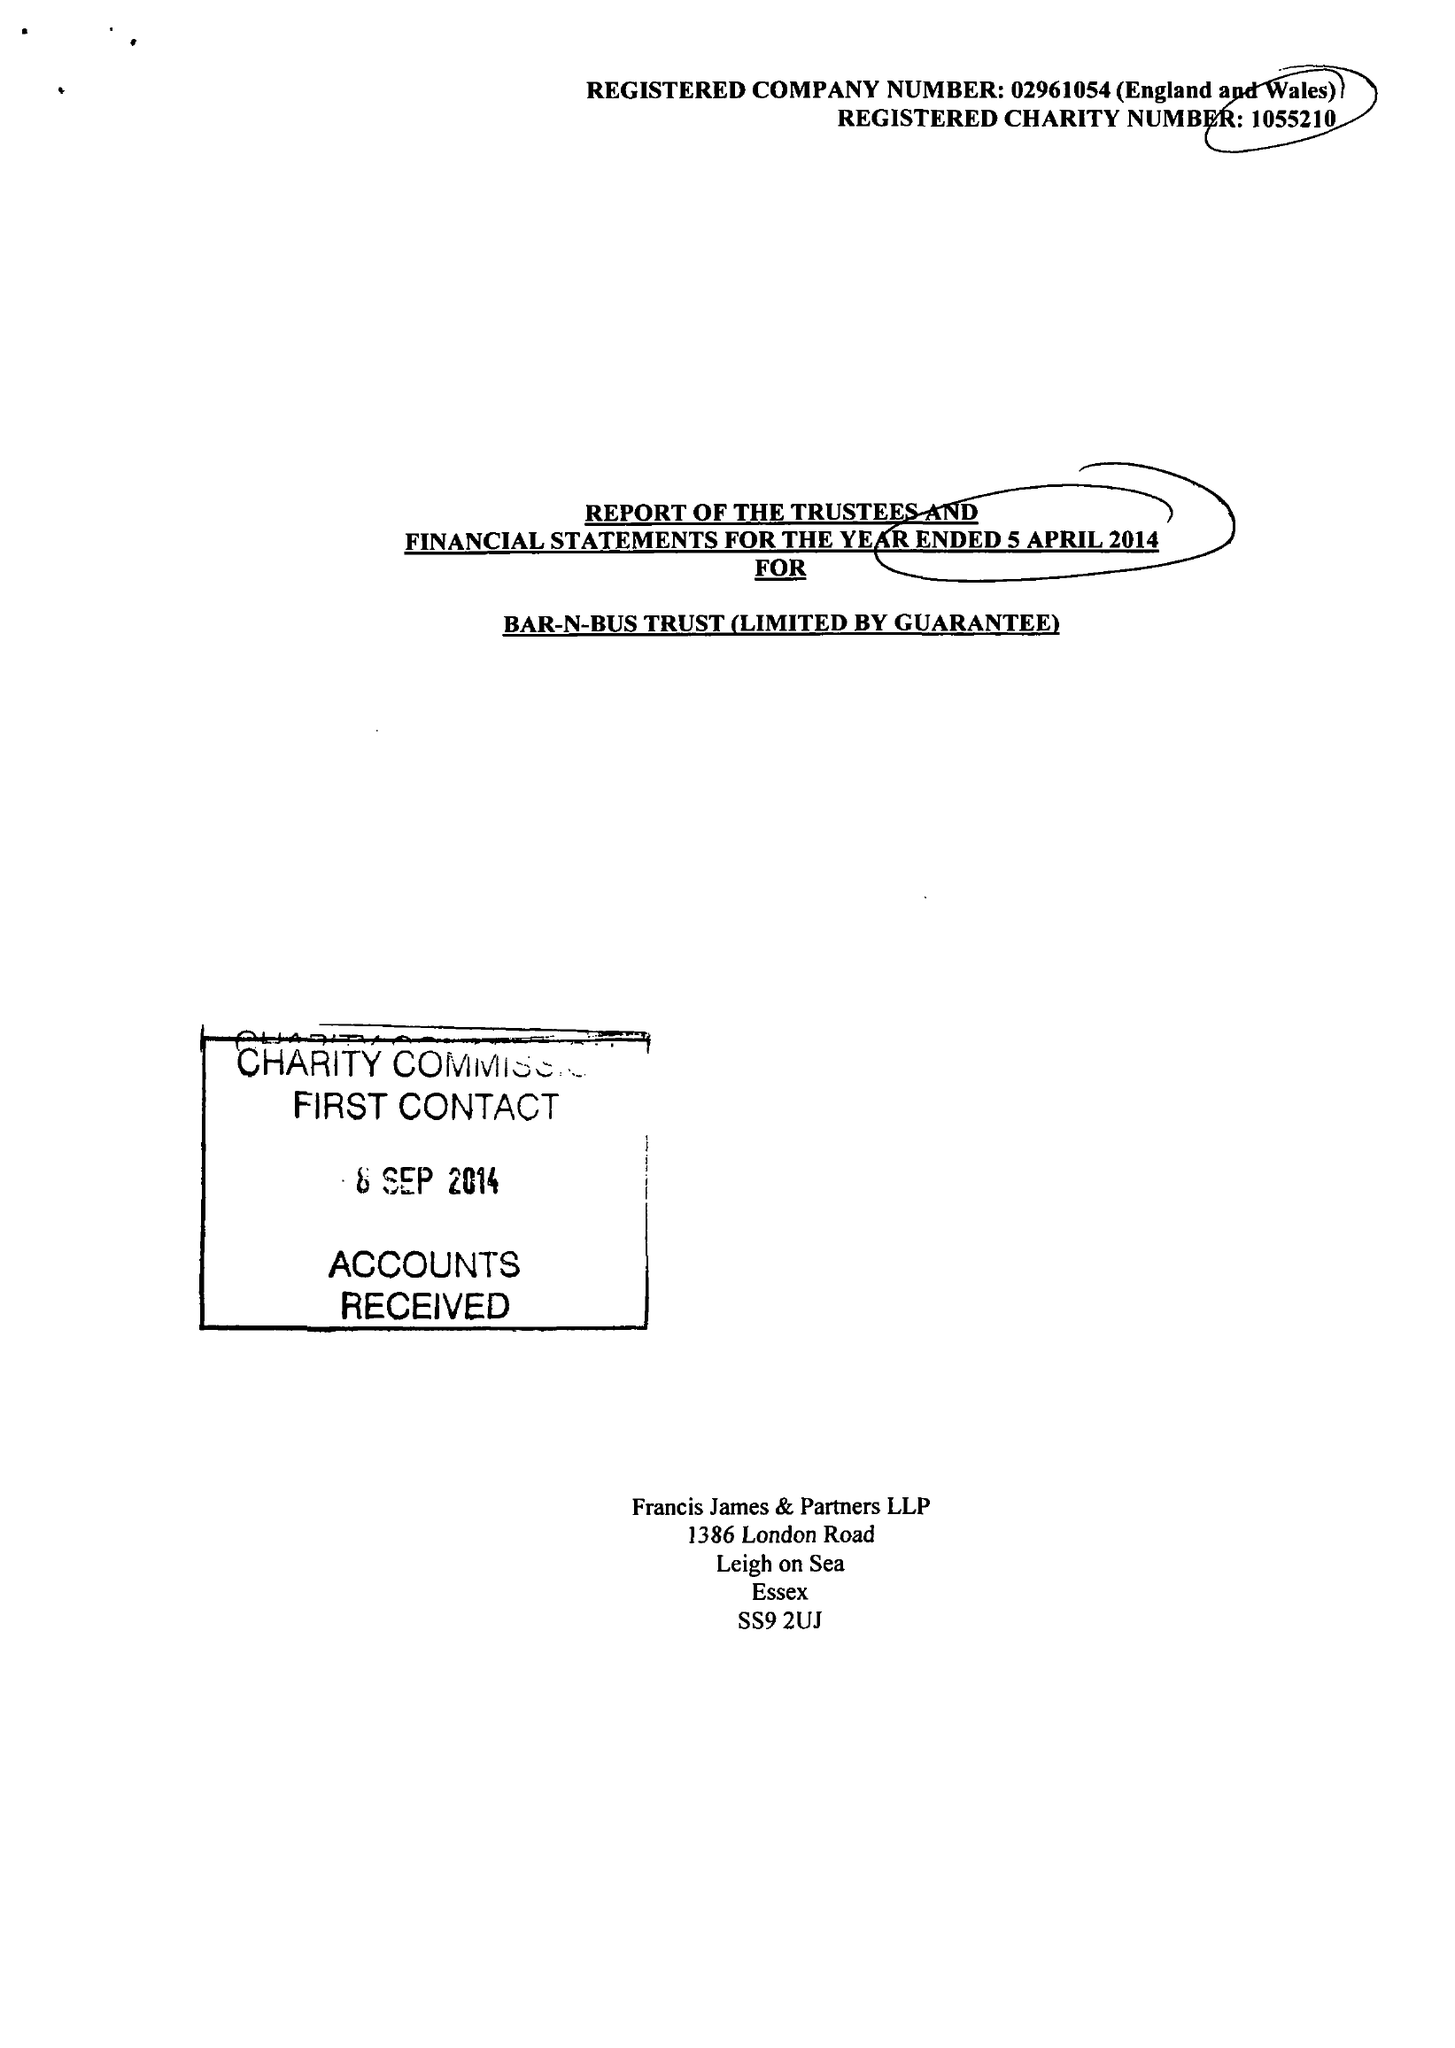What is the value for the address__post_town?
Answer the question using a single word or phrase. LEIGH-ON-SEA 